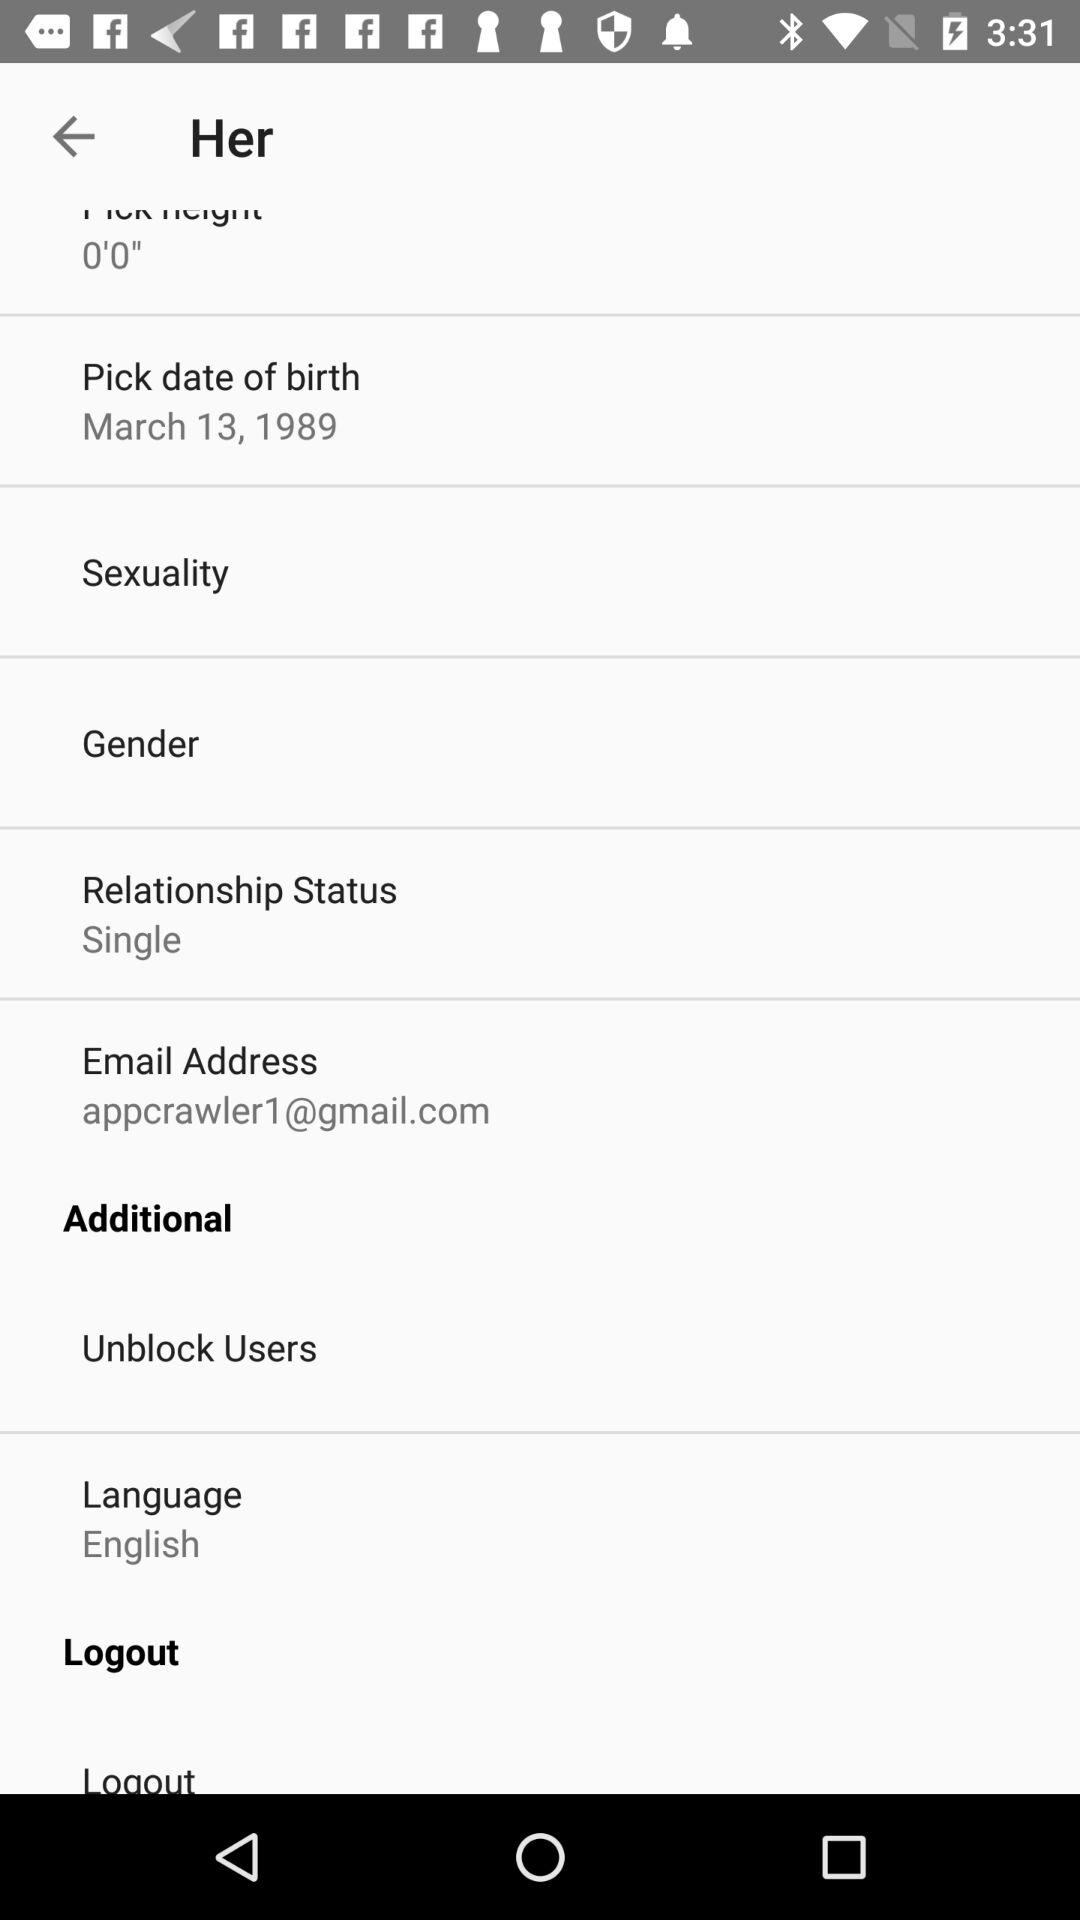What is the pick date of birth? The date of birth is March 13, 1989. 